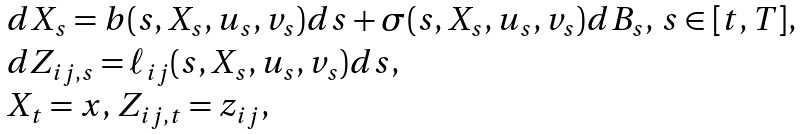<formula> <loc_0><loc_0><loc_500><loc_500>\begin{array} { l } d X _ { s } = b ( s , X _ { s } , u _ { s } , v _ { s } ) d s + \sigma ( s , X _ { s } , u _ { s } , v _ { s } ) d B _ { s } , \, s \in [ t , T ] , \\ d Z _ { i j , s } = \ell _ { i j } ( s , X _ { s } , u _ { s } , v _ { s } ) d s , \\ X _ { t } = x , \, Z _ { i j , t } = z _ { i j } , \end{array}</formula> 